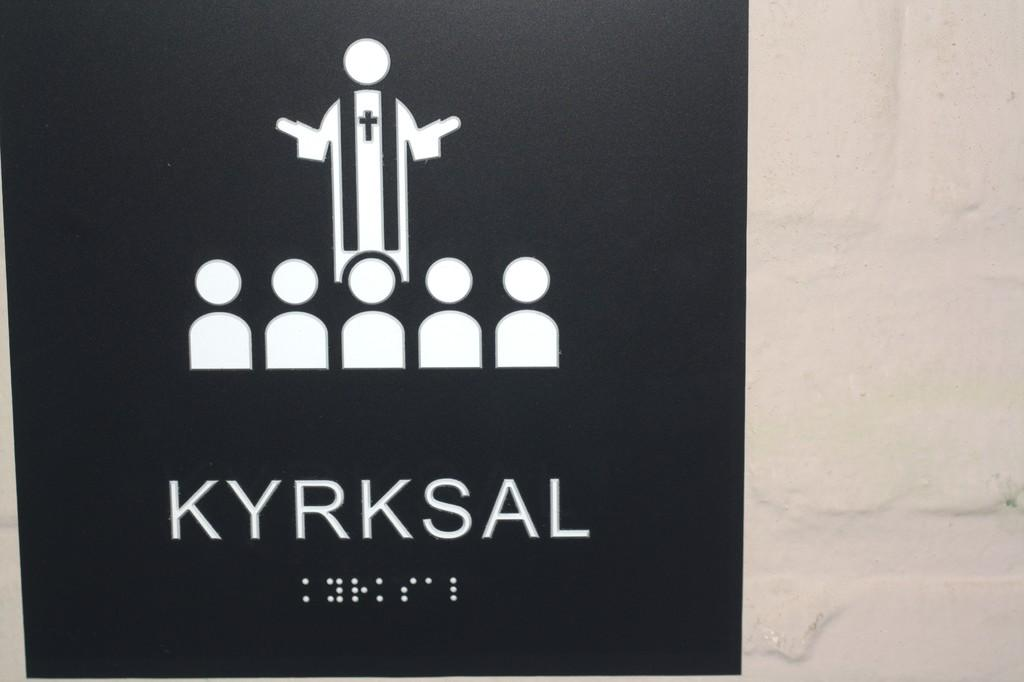<image>
Create a compact narrative representing the image presented. A sign that shows a priest preaching to people and read Kyrksal. 